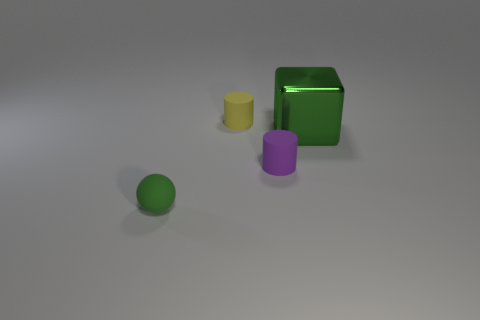Add 3 green shiny objects. How many objects exist? 7 Subtract all yellow things. Subtract all yellow matte things. How many objects are left? 2 Add 3 matte spheres. How many matte spheres are left? 4 Add 4 large purple balls. How many large purple balls exist? 4 Subtract 0 gray spheres. How many objects are left? 4 